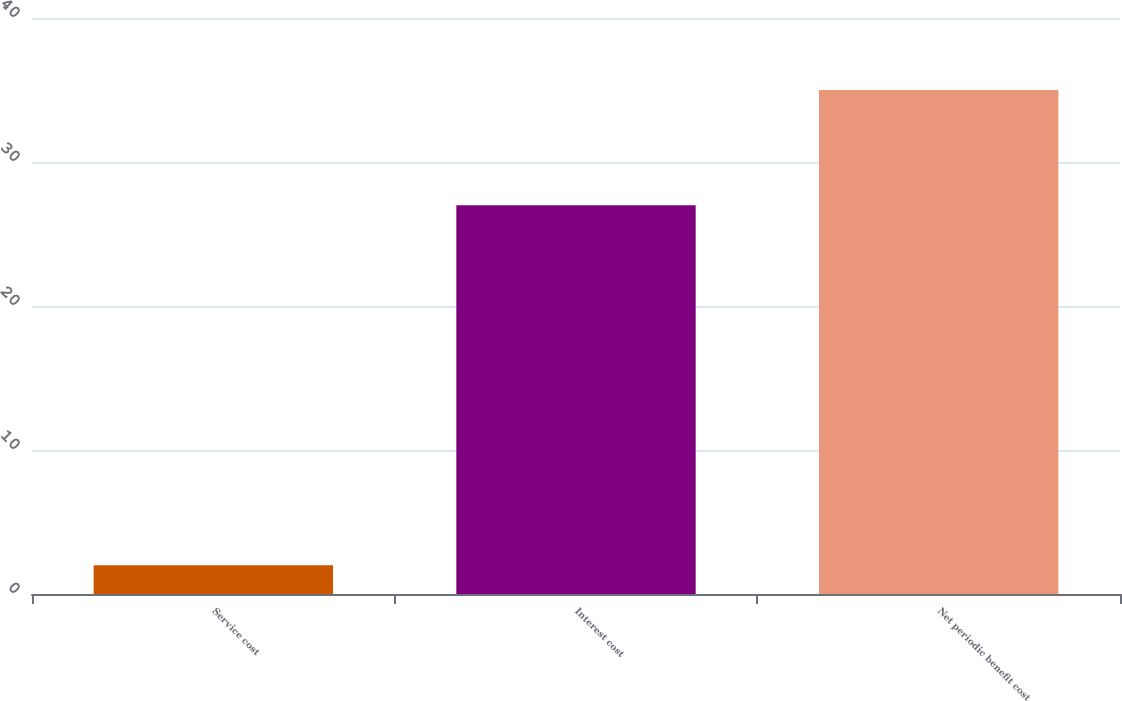<chart> <loc_0><loc_0><loc_500><loc_500><bar_chart><fcel>Service cost<fcel>Interest cost<fcel>Net periodic benefit cost<nl><fcel>2<fcel>27<fcel>35<nl></chart> 